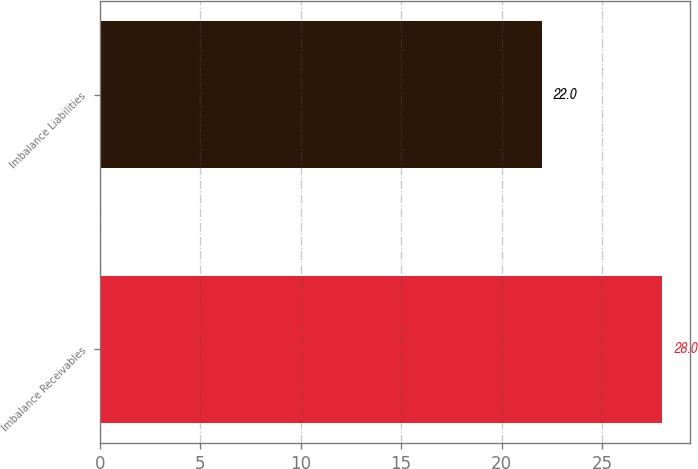Convert chart. <chart><loc_0><loc_0><loc_500><loc_500><bar_chart><fcel>Imbalance Receivables<fcel>Imbalance Liabilities<nl><fcel>28<fcel>22<nl></chart> 